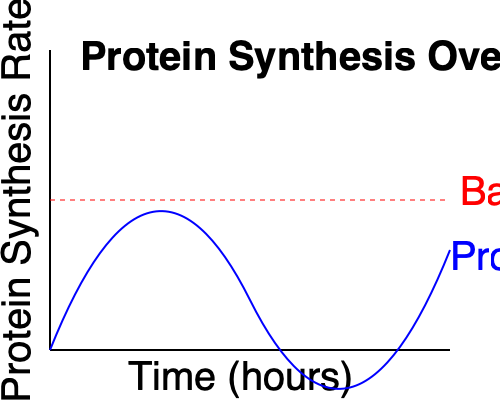As the undisputed champion of muscle growth, you're presented with a graph showing protein synthesis rates over time after a intense workout. Identify the optimal time window for maximizing muscle growth and recovery, and explain how you would adjust your nutrition strategy to capitalize on this anabolic window. How does this knowledge give you an edge over your competitors? To answer this question, we need to analyze the graph and understand the protein synthesis process:

1. Baseline protein synthesis: The red dashed line represents the normal rate of protein synthesis.

2. Anabolic window: The period after exercise where protein synthesis is elevated above baseline.

3. Peak protein synthesis: The highest point on the blue curve, occurring approximately 2-3 hours post-workout.

4. Duration of elevated synthesis: The protein synthesis rate remains above baseline for about 24-48 hours, gradually returning to normal.

5. Optimal time window: The period from immediately post-workout to about 24 hours later, when protein synthesis is significantly elevated.

To maximize muscle growth and recovery:

1. Consume a fast-absorbing protein source (e.g., whey) immediately post-workout to kickstart protein synthesis.

2. Ingest a slower-absorbing protein (e.g., casein) before bed to sustain elevated protein synthesis during sleep.

3. Maintain a high-protein diet throughout the day to support the extended anabolic window.

4. Time larger meals to coincide with peak protein synthesis (2-3 hours post-workout).

5. Ensure adequate carbohydrate intake to replenish glycogen stores and support protein synthesis.

This strategy gives an edge by:

1. Maximizing the body's natural anabolic response to exercise.
2. Optimizing nutrient timing for faster recovery and growth.
3. Sustaining muscle protein synthesis for longer periods, potentially leading to greater muscle gains.
4. Reducing muscle breakdown and enhancing overall recovery.
Answer: Consume fast-absorbing protein immediately post-workout, slow-absorbing protein before bed, and maintain high protein intake for 24-48 hours to maximize the extended anabolic window. 